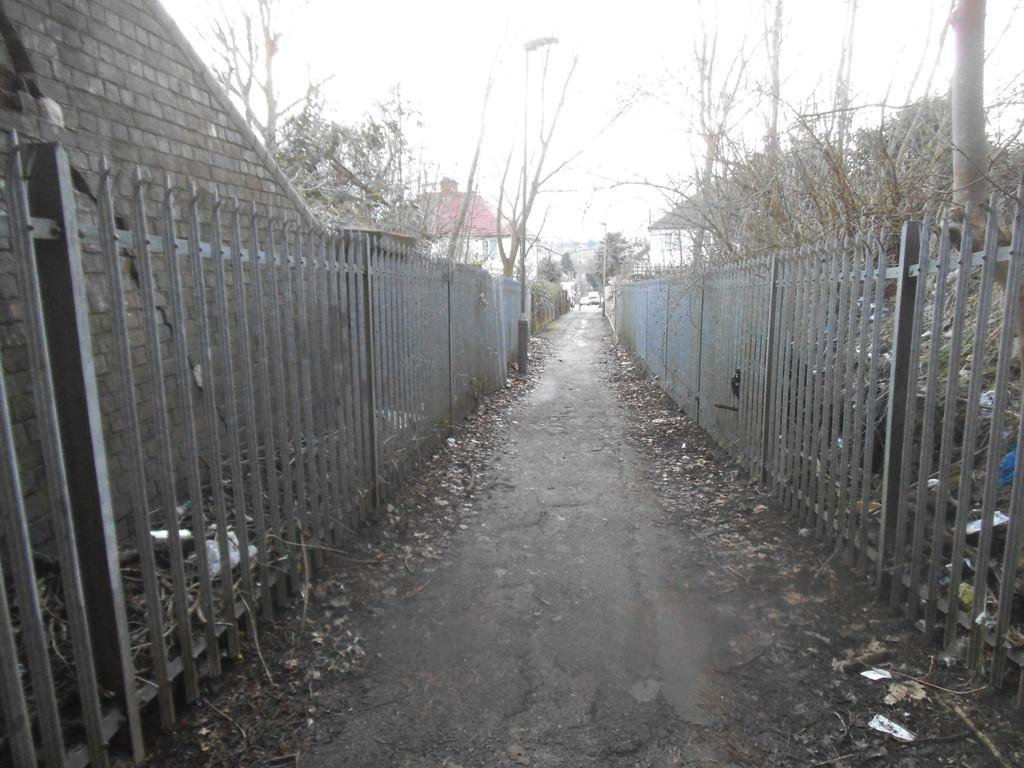What type of material is the fencing in the image made of? The fencing in the image is made of metal. What other elements can be seen in the image besides the fencing? There are plants and a pole visible in the image. What can be seen in the background of the image? The sky is visible in the image. What type of sock is hanging on the pole in the image? There is no sock present in the image; it only features metal fencing, plants, and a pole. 